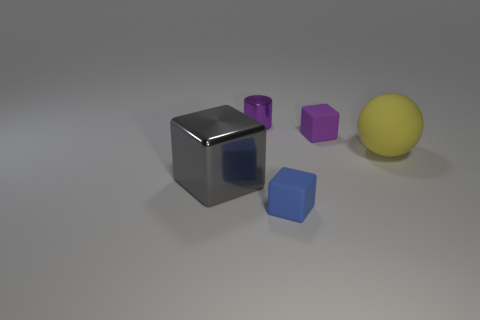Add 3 tiny purple metallic cylinders. How many objects exist? 8 Subtract all spheres. How many objects are left? 4 Subtract all big cubes. Subtract all tiny blue rubber cubes. How many objects are left? 3 Add 3 big yellow objects. How many big yellow objects are left? 4 Add 2 tiny gray matte things. How many tiny gray matte things exist? 2 Subtract 0 brown balls. How many objects are left? 5 